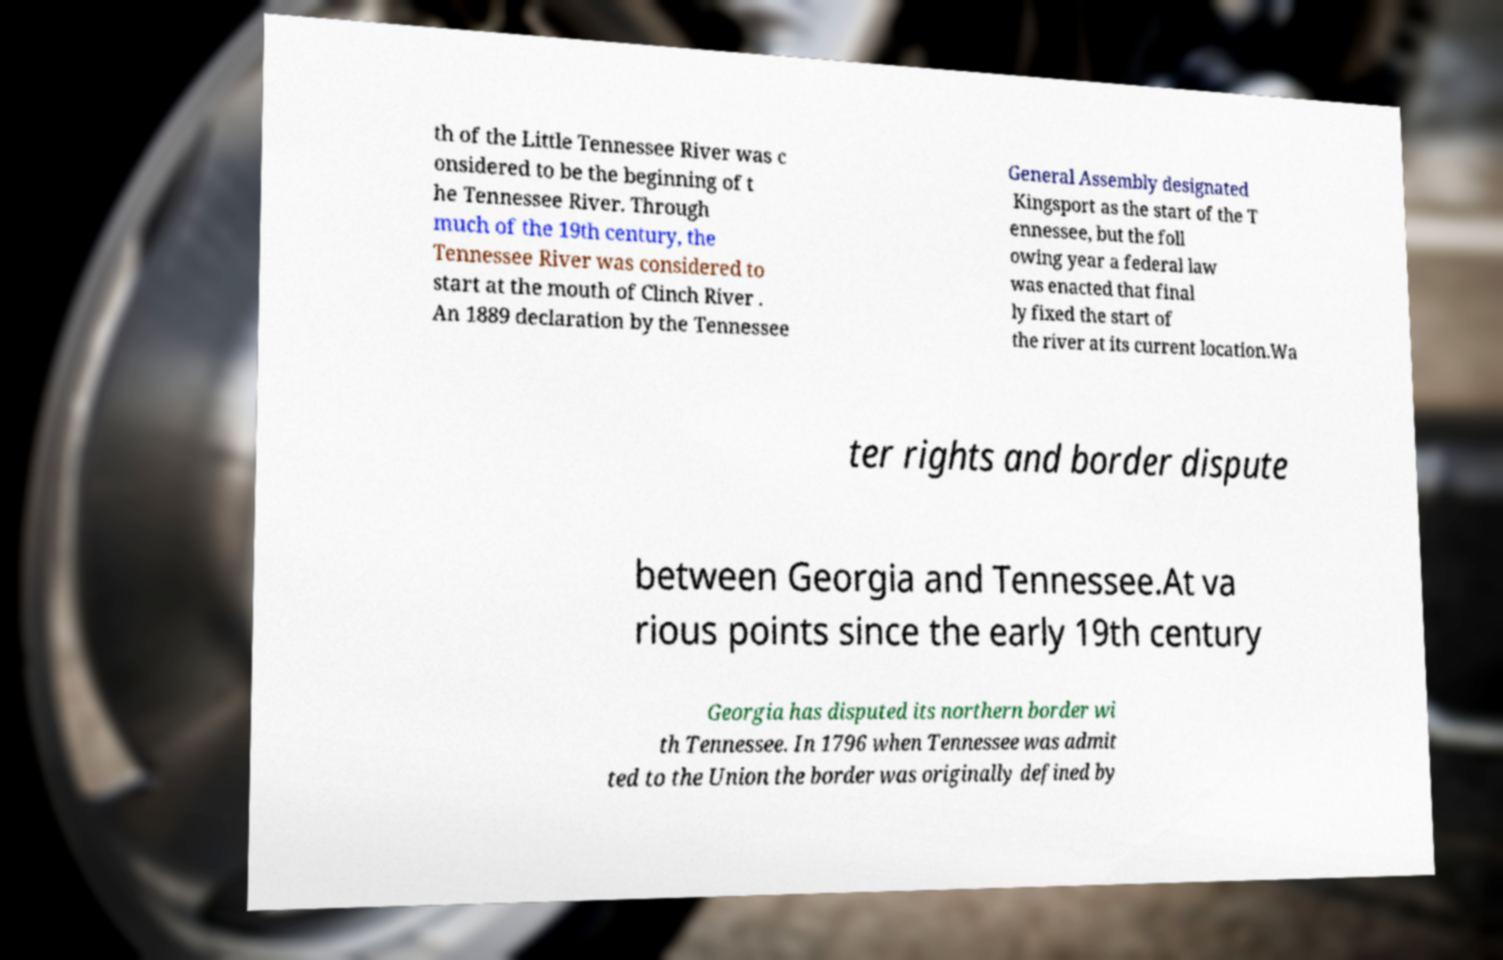Can you accurately transcribe the text from the provided image for me? th of the Little Tennessee River was c onsidered to be the beginning of t he Tennessee River. Through much of the 19th century, the Tennessee River was considered to start at the mouth of Clinch River . An 1889 declaration by the Tennessee General Assembly designated Kingsport as the start of the T ennessee, but the foll owing year a federal law was enacted that final ly fixed the start of the river at its current location.Wa ter rights and border dispute between Georgia and Tennessee.At va rious points since the early 19th century Georgia has disputed its northern border wi th Tennessee. In 1796 when Tennessee was admit ted to the Union the border was originally defined by 